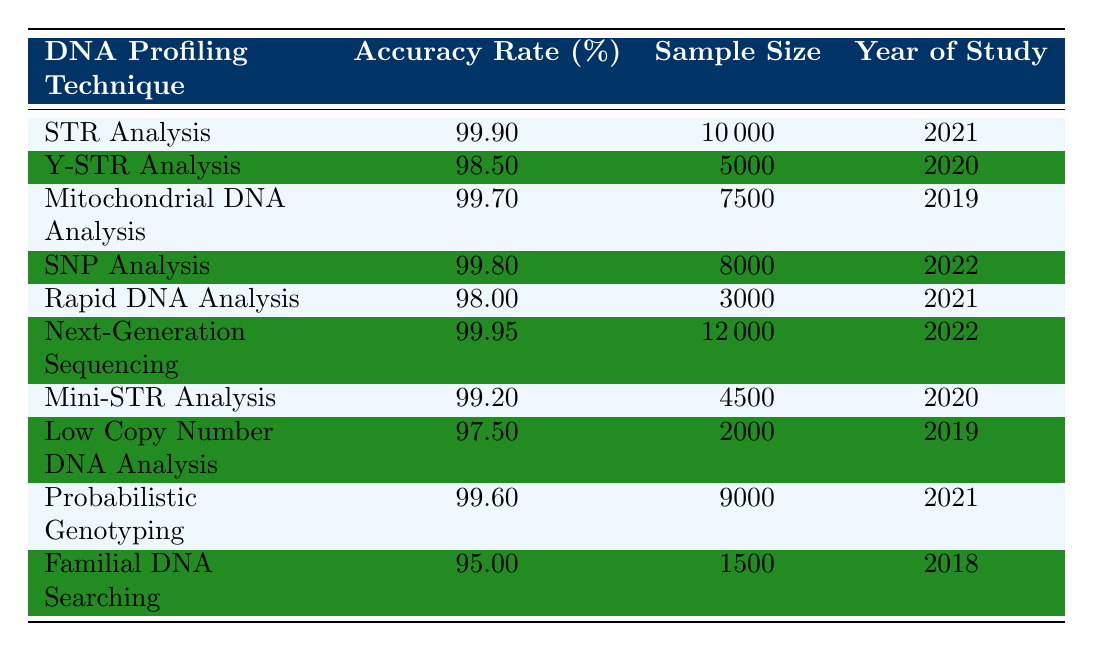What is the accuracy rate of STR Analysis? The accuracy rate of STR Analysis is directly stated in the table under the "Accuracy Rate (%)" column corresponding to the "STR Analysis" technique. The value is 99.9.
Answer: 99.9 Which DNA profiling technique had the highest accuracy rate? By examining the "Accuracy Rate (%)" column, the highest value is found for "Next-Generation Sequencing," which has an accuracy rate of 99.95.
Answer: Next-Generation Sequencing What is the sample size for Familial DNA Searching? The sample size for Familial DNA Searching can be located in the "Sample Size" column aligned with "Familial DNA Searching." The value is 1500.
Answer: 1500 What is the average accuracy rate of the DNA profiling techniques listed? To calculate the average accuracy rate, sum all accuracy rates: 99.9 + 98.5 + 99.7 + 99.8 + 98.0 + 99.95 + 99.2 + 97.5 + 99.6 + 95.0 = 995.4. The total number of techniques is 10, so the average is 995.4 / 10 = 99.54.
Answer: 99.54 Is the accuracy rate of Low Copy Number DNA Analysis above 98%? Observing the accuracy rate for Low Copy Number DNA Analysis, which is 97.5, it is clear that this value is below 98%. Therefore, the answer is no.
Answer: No How many techniques have an accuracy rate of 99% or higher? By reviewing each row in the "Accuracy Rate (%)" column, we find that the techniques with rates of 99% or higher are STR Analysis, Mitochondrial DNA Analysis, SNP Analysis, Next-Generation Sequencing, and Probabilistic Genotyping. That totals 5 techniques.
Answer: 5 What is the sample size for the technique with the lowest accuracy rate? The technique with the lowest accuracy rate listed is Familial DNA Searching with an accuracy rate of 95.0. Checking the sample size column for this technique shows it to be 1500.
Answer: 1500 Was the study for Y-STR Analysis conducted in a year greater than 2019? The year of study for Y-STR Analysis is 2020. Since 2020 is greater than 2019, the answer is yes.
Answer: Yes What is the difference in accuracy rates between Rapid DNA Analysis and Mitochondrial DNA Analysis? The accuracy rate for Rapid DNA Analysis is 98.0, and for Mitochondrial DNA Analysis, it is 99.7. The difference is calculated by subtracting: 99.7 - 98.0 = 1.7.
Answer: 1.7 